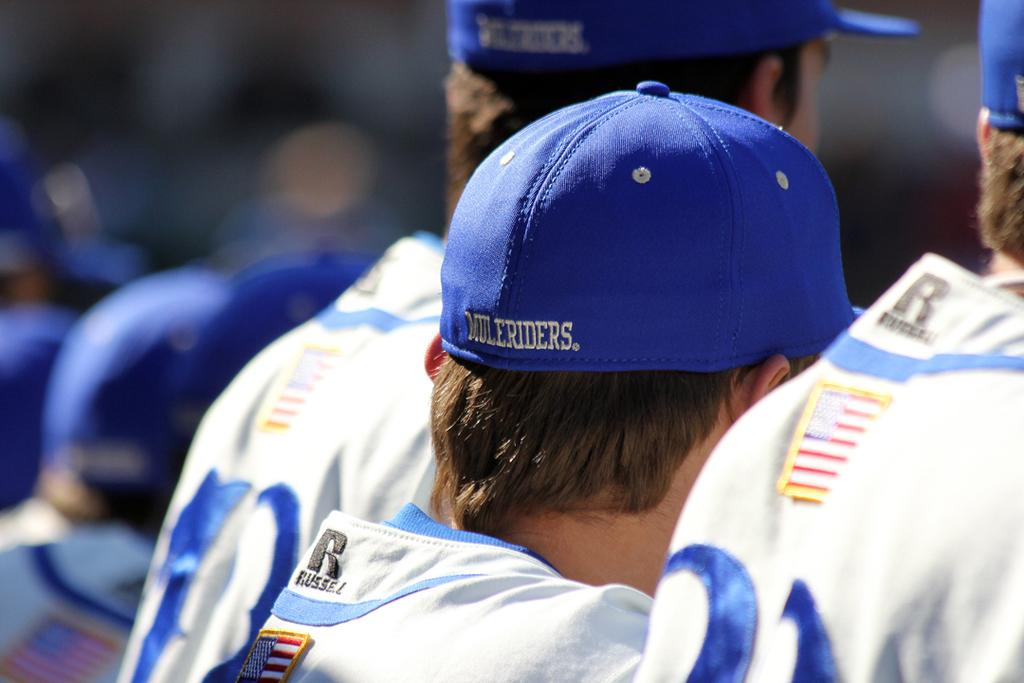<image>
Share a concise interpretation of the image provided. a man wearing a white tee shirt emblazoned with the insignia Russell and a small american flag below it. 